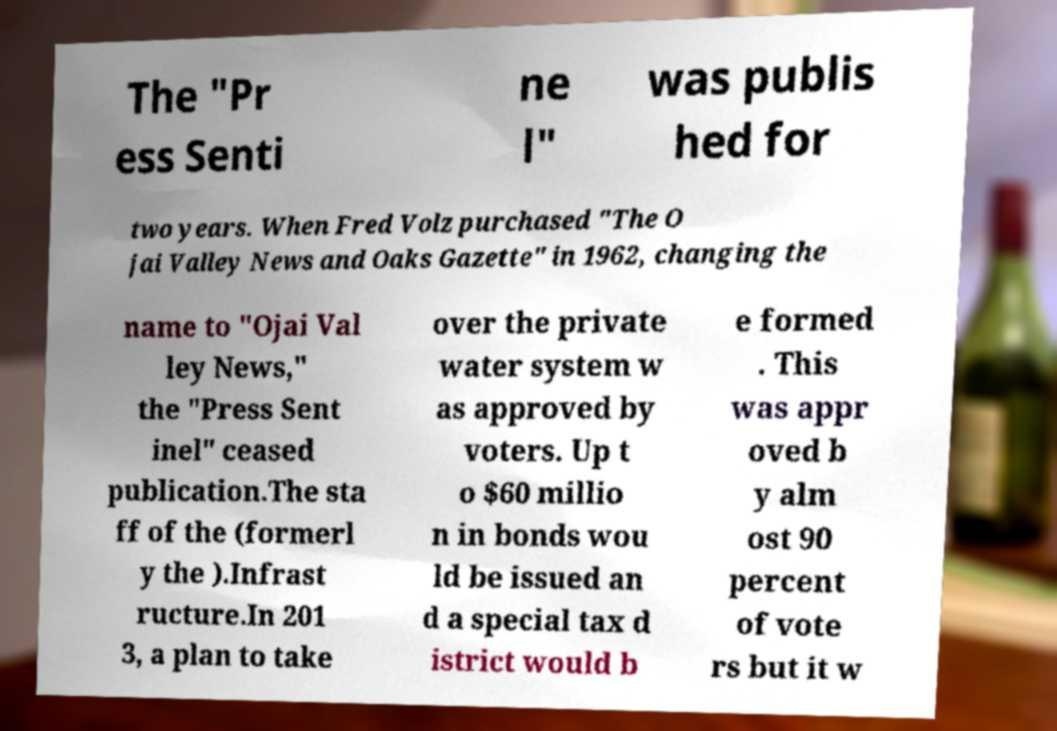Can you read and provide the text displayed in the image?This photo seems to have some interesting text. Can you extract and type it out for me? The "Pr ess Senti ne l" was publis hed for two years. When Fred Volz purchased "The O jai Valley News and Oaks Gazette" in 1962, changing the name to "Ojai Val ley News," the "Press Sent inel" ceased publication.The sta ff of the (formerl y the ).Infrast ructure.In 201 3, a plan to take over the private water system w as approved by voters. Up t o $60 millio n in bonds wou ld be issued an d a special tax d istrict would b e formed . This was appr oved b y alm ost 90 percent of vote rs but it w 